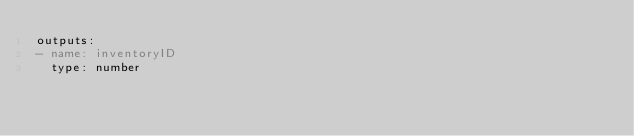Convert code to text. <code><loc_0><loc_0><loc_500><loc_500><_YAML_>outputs:
- name: inventoryID
  type: number
</code> 